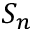Convert formula to latex. <formula><loc_0><loc_0><loc_500><loc_500>S _ { n }</formula> 